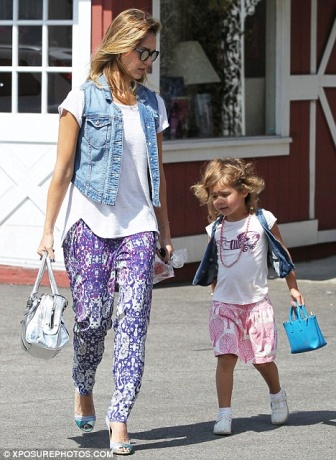If this image was part of a story, what would the next scene be? In the next scene of this story, they might arrive at a quaint café nearby. The mother could find a cozy spot by the window, sipping on a freshly brewed coffee while the daughter gets a small treat like ice cream or a pastry. They continue chatting, the mother smiling warmly at her daughter’s animated stories about her day. The café is filled with the gentle hum of background conversations and soft music, adding to the comforting atmosphere of their bonding time. Imagine this image is from a fantasy world. What magical elements could be hiding in it? In a fantasy world, the denim vest worn by the mother might have enchanted pockets that can store unlimited items, making it the ultimate shopping companion. The blue bag clutched by the daughter could be a magical purse that transforms into different objects she needs throughout the day, from a toy to a protective charm. The building behind them could be a facade for a hidden magical library, where tomes of ancient spells and fantastical creatures are kept, awaiting discovery by those who believe in magic. 